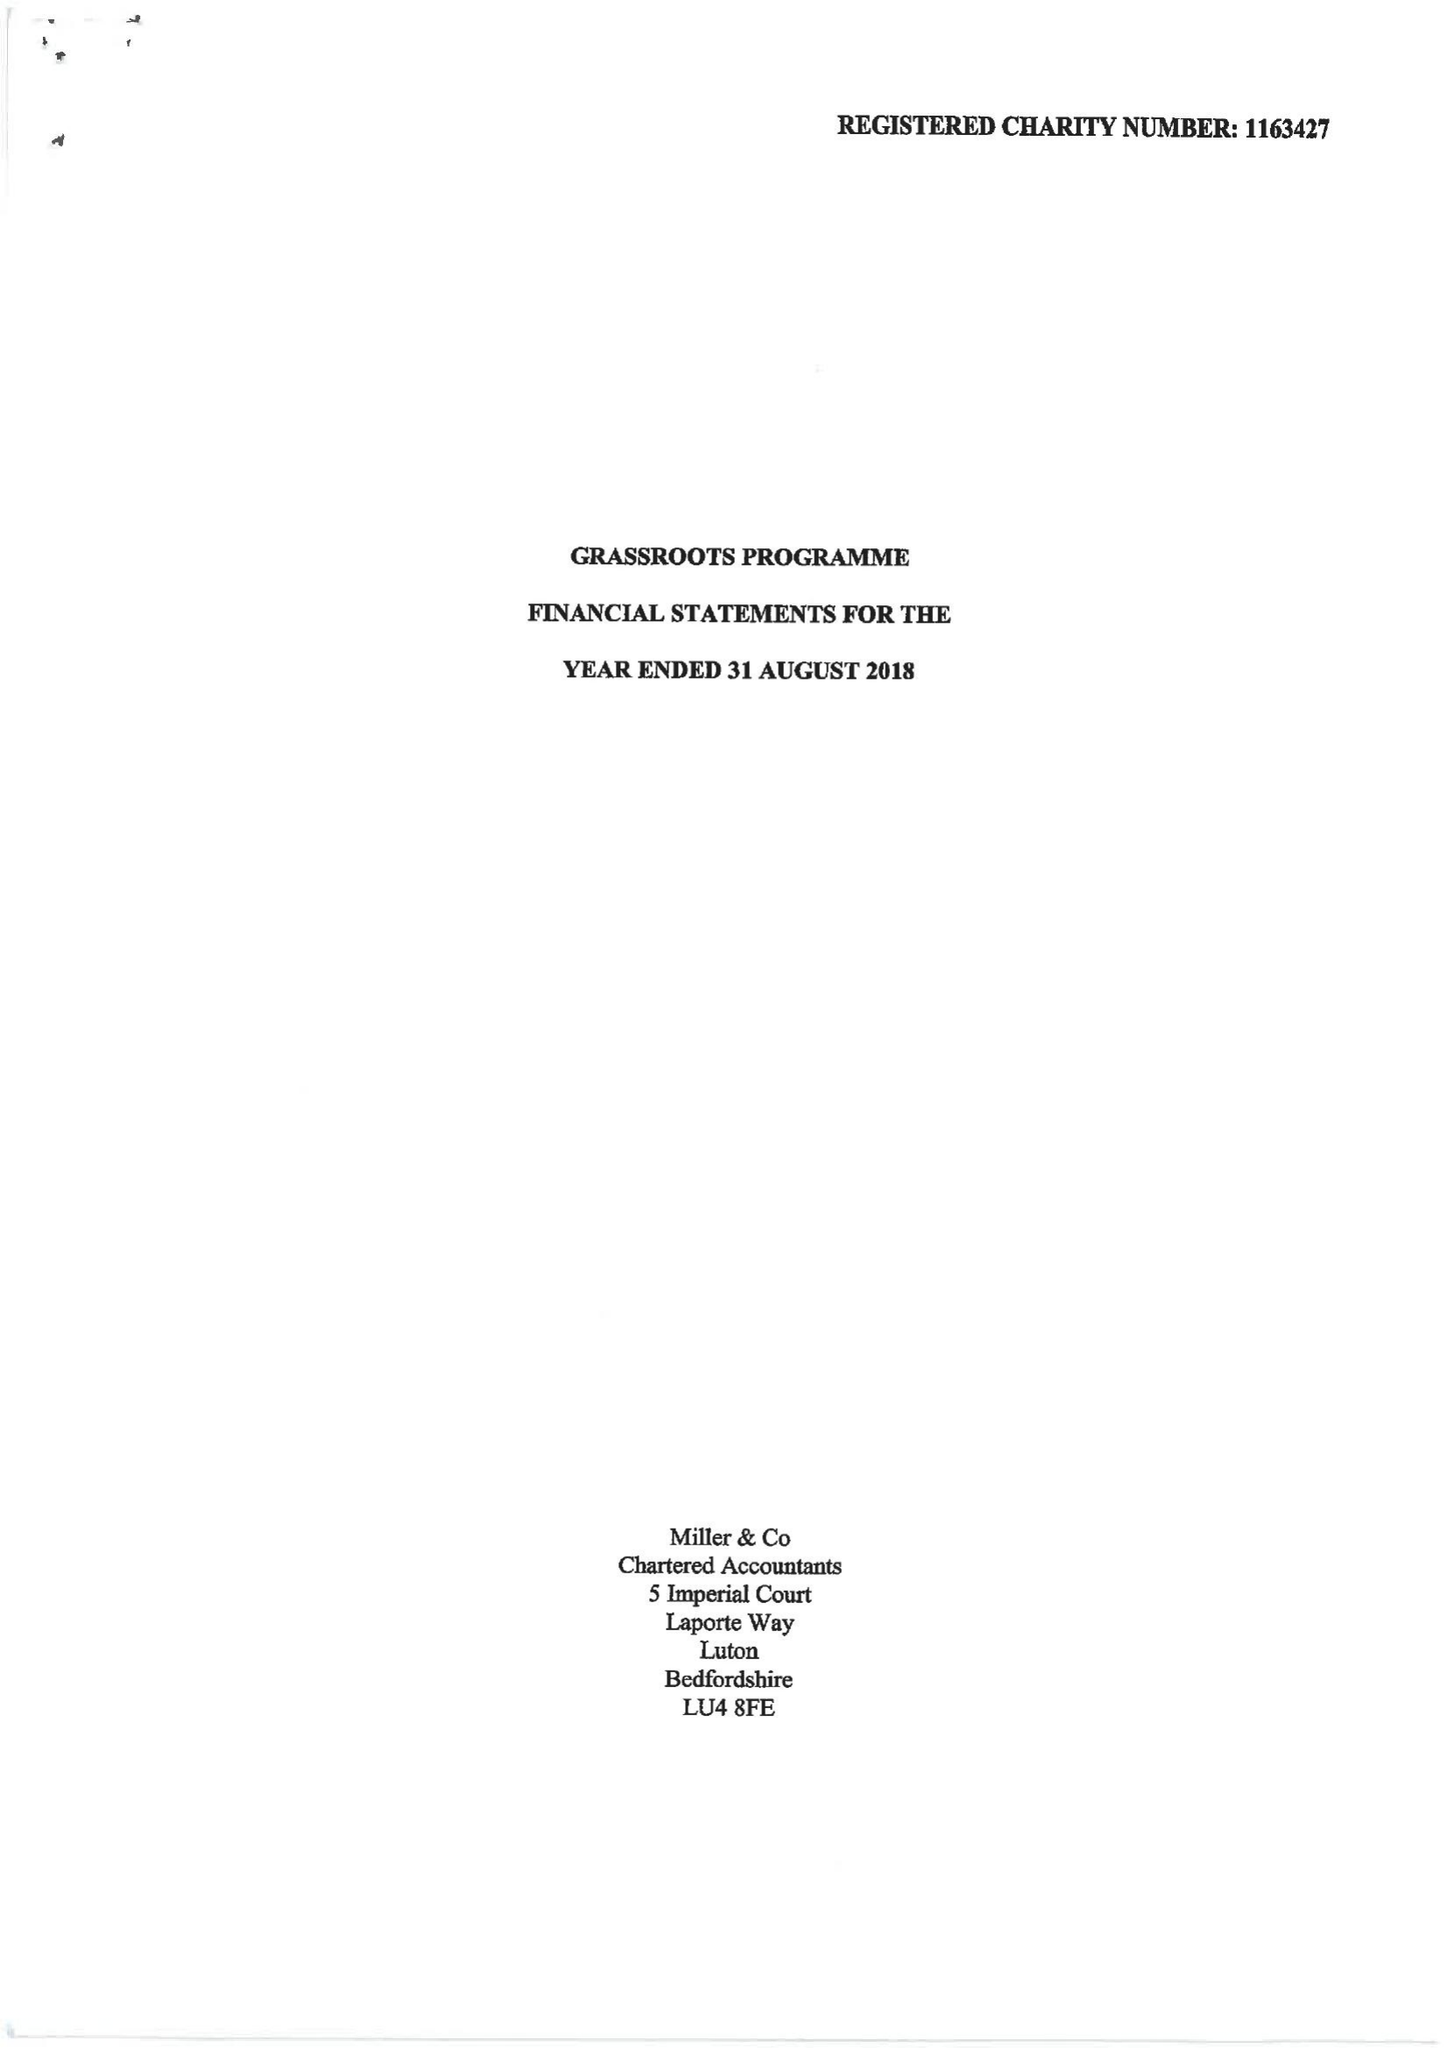What is the value for the report_date?
Answer the question using a single word or phrase. 2018-08-31 